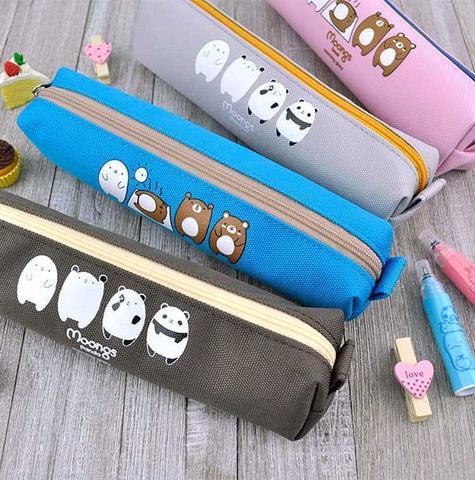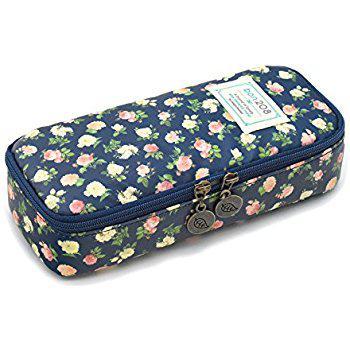The first image is the image on the left, the second image is the image on the right. Examine the images to the left and right. Is the description "One of the cases in the image on the right is open." accurate? Answer yes or no. No. The first image is the image on the left, the second image is the image on the right. Assess this claim about the two images: "No image shows a pencil case that is opened.". Correct or not? Answer yes or no. Yes. 